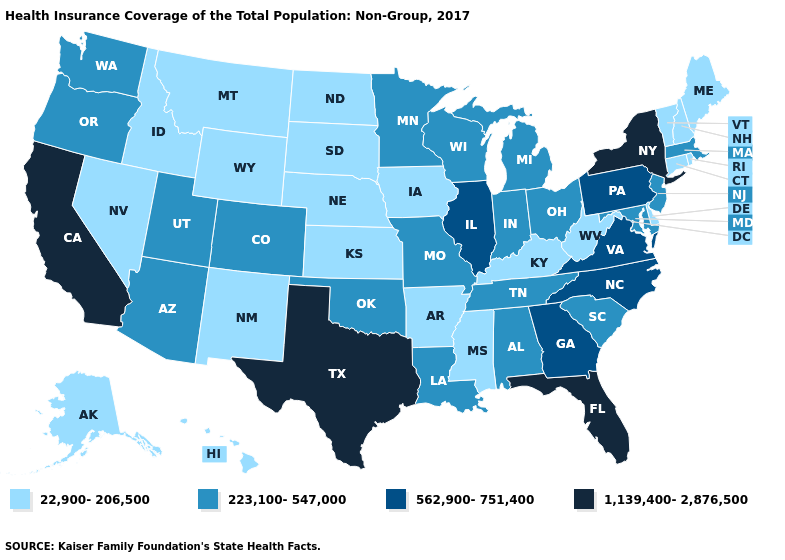What is the highest value in the South ?
Keep it brief. 1,139,400-2,876,500. Does Wyoming have the highest value in the West?
Write a very short answer. No. What is the value of Washington?
Short answer required. 223,100-547,000. Name the states that have a value in the range 223,100-547,000?
Be succinct. Alabama, Arizona, Colorado, Indiana, Louisiana, Maryland, Massachusetts, Michigan, Minnesota, Missouri, New Jersey, Ohio, Oklahoma, Oregon, South Carolina, Tennessee, Utah, Washington, Wisconsin. What is the value of Oklahoma?
Keep it brief. 223,100-547,000. Which states have the lowest value in the USA?
Be succinct. Alaska, Arkansas, Connecticut, Delaware, Hawaii, Idaho, Iowa, Kansas, Kentucky, Maine, Mississippi, Montana, Nebraska, Nevada, New Hampshire, New Mexico, North Dakota, Rhode Island, South Dakota, Vermont, West Virginia, Wyoming. What is the highest value in states that border Maine?
Write a very short answer. 22,900-206,500. Name the states that have a value in the range 22,900-206,500?
Keep it brief. Alaska, Arkansas, Connecticut, Delaware, Hawaii, Idaho, Iowa, Kansas, Kentucky, Maine, Mississippi, Montana, Nebraska, Nevada, New Hampshire, New Mexico, North Dakota, Rhode Island, South Dakota, Vermont, West Virginia, Wyoming. Among the states that border Kansas , which have the highest value?
Quick response, please. Colorado, Missouri, Oklahoma. What is the lowest value in the Northeast?
Quick response, please. 22,900-206,500. Which states have the lowest value in the Northeast?
Concise answer only. Connecticut, Maine, New Hampshire, Rhode Island, Vermont. Name the states that have a value in the range 1,139,400-2,876,500?
Short answer required. California, Florida, New York, Texas. Does Wisconsin have a higher value than Montana?
Answer briefly. Yes. Does Iowa have the same value as New York?
Write a very short answer. No. 